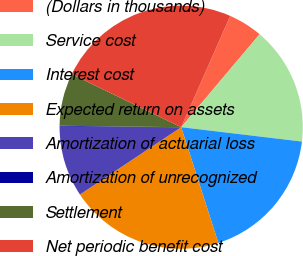<chart> <loc_0><loc_0><loc_500><loc_500><pie_chart><fcel>(Dollars in thousands)<fcel>Service cost<fcel>Interest cost<fcel>Expected return on assets<fcel>Amortization of actuarial loss<fcel>Amortization of unrecognized<fcel>Settlement<fcel>Net periodic benefit cost<nl><fcel>4.55%<fcel>15.73%<fcel>18.17%<fcel>20.6%<fcel>9.42%<fcel>0.11%<fcel>6.99%<fcel>24.43%<nl></chart> 